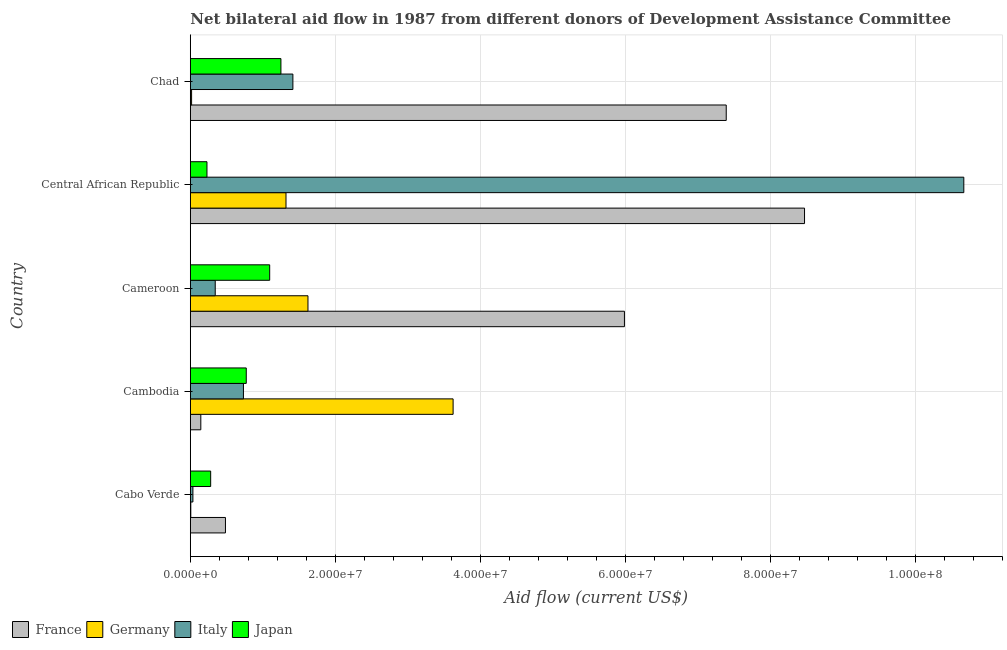How many different coloured bars are there?
Offer a very short reply. 4. How many groups of bars are there?
Your response must be concise. 5. Are the number of bars per tick equal to the number of legend labels?
Offer a terse response. Yes. Are the number of bars on each tick of the Y-axis equal?
Offer a very short reply. Yes. How many bars are there on the 2nd tick from the bottom?
Keep it short and to the point. 4. What is the label of the 2nd group of bars from the top?
Give a very brief answer. Central African Republic. What is the amount of aid given by germany in Cameroon?
Give a very brief answer. 1.62e+07. Across all countries, what is the maximum amount of aid given by italy?
Offer a very short reply. 1.07e+08. Across all countries, what is the minimum amount of aid given by france?
Your response must be concise. 1.45e+06. In which country was the amount of aid given by italy maximum?
Offer a terse response. Central African Republic. In which country was the amount of aid given by france minimum?
Provide a short and direct response. Cambodia. What is the total amount of aid given by france in the graph?
Your answer should be compact. 2.25e+08. What is the difference between the amount of aid given by italy in Cabo Verde and that in Cameroon?
Your answer should be compact. -3.08e+06. What is the difference between the amount of aid given by italy in Central African Republic and the amount of aid given by germany in Cabo Verde?
Offer a terse response. 1.07e+08. What is the average amount of aid given by italy per country?
Your answer should be very brief. 2.64e+07. What is the difference between the amount of aid given by germany and amount of aid given by italy in Cameroon?
Your answer should be very brief. 1.28e+07. What is the ratio of the amount of aid given by italy in Cabo Verde to that in Chad?
Your answer should be compact. 0.03. Is the amount of aid given by japan in Cameroon less than that in Chad?
Keep it short and to the point. Yes. What is the difference between the highest and the second highest amount of aid given by france?
Give a very brief answer. 1.08e+07. What is the difference between the highest and the lowest amount of aid given by france?
Provide a short and direct response. 8.33e+07. Is the sum of the amount of aid given by japan in Cambodia and Central African Republic greater than the maximum amount of aid given by italy across all countries?
Keep it short and to the point. No. Is it the case that in every country, the sum of the amount of aid given by italy and amount of aid given by france is greater than the sum of amount of aid given by japan and amount of aid given by germany?
Offer a very short reply. No. What does the 3rd bar from the top in Chad represents?
Your answer should be compact. Germany. Is it the case that in every country, the sum of the amount of aid given by france and amount of aid given by germany is greater than the amount of aid given by italy?
Make the answer very short. No. How many bars are there?
Offer a very short reply. 20. Are all the bars in the graph horizontal?
Provide a succinct answer. Yes. How many countries are there in the graph?
Make the answer very short. 5. Does the graph contain any zero values?
Provide a succinct answer. No. Does the graph contain grids?
Provide a succinct answer. Yes. Where does the legend appear in the graph?
Offer a terse response. Bottom left. What is the title of the graph?
Provide a succinct answer. Net bilateral aid flow in 1987 from different donors of Development Assistance Committee. Does "Agricultural land" appear as one of the legend labels in the graph?
Provide a succinct answer. No. What is the label or title of the Y-axis?
Your answer should be compact. Country. What is the Aid flow (current US$) in France in Cabo Verde?
Provide a short and direct response. 4.85e+06. What is the Aid flow (current US$) in Germany in Cabo Verde?
Offer a very short reply. 7.00e+04. What is the Aid flow (current US$) of Japan in Cabo Verde?
Offer a terse response. 2.81e+06. What is the Aid flow (current US$) of France in Cambodia?
Make the answer very short. 1.45e+06. What is the Aid flow (current US$) of Germany in Cambodia?
Ensure brevity in your answer.  3.62e+07. What is the Aid flow (current US$) in Italy in Cambodia?
Make the answer very short. 7.33e+06. What is the Aid flow (current US$) in Japan in Cambodia?
Make the answer very short. 7.72e+06. What is the Aid flow (current US$) of France in Cameroon?
Your answer should be very brief. 5.99e+07. What is the Aid flow (current US$) of Germany in Cameroon?
Provide a short and direct response. 1.62e+07. What is the Aid flow (current US$) in Italy in Cameroon?
Provide a short and direct response. 3.44e+06. What is the Aid flow (current US$) in Japan in Cameroon?
Your answer should be compact. 1.10e+07. What is the Aid flow (current US$) in France in Central African Republic?
Provide a succinct answer. 8.47e+07. What is the Aid flow (current US$) of Germany in Central African Republic?
Provide a succinct answer. 1.32e+07. What is the Aid flow (current US$) of Italy in Central African Republic?
Offer a very short reply. 1.07e+08. What is the Aid flow (current US$) of Japan in Central African Republic?
Your answer should be compact. 2.30e+06. What is the Aid flow (current US$) in France in Chad?
Provide a short and direct response. 7.39e+07. What is the Aid flow (current US$) of Germany in Chad?
Provide a short and direct response. 1.80e+05. What is the Aid flow (current US$) of Italy in Chad?
Give a very brief answer. 1.42e+07. What is the Aid flow (current US$) of Japan in Chad?
Give a very brief answer. 1.25e+07. Across all countries, what is the maximum Aid flow (current US$) in France?
Your response must be concise. 8.47e+07. Across all countries, what is the maximum Aid flow (current US$) of Germany?
Your response must be concise. 3.62e+07. Across all countries, what is the maximum Aid flow (current US$) of Italy?
Offer a very short reply. 1.07e+08. Across all countries, what is the maximum Aid flow (current US$) of Japan?
Ensure brevity in your answer.  1.25e+07. Across all countries, what is the minimum Aid flow (current US$) of France?
Make the answer very short. 1.45e+06. Across all countries, what is the minimum Aid flow (current US$) of Germany?
Keep it short and to the point. 7.00e+04. Across all countries, what is the minimum Aid flow (current US$) in Japan?
Ensure brevity in your answer.  2.30e+06. What is the total Aid flow (current US$) in France in the graph?
Ensure brevity in your answer.  2.25e+08. What is the total Aid flow (current US$) of Germany in the graph?
Your response must be concise. 6.59e+07. What is the total Aid flow (current US$) of Italy in the graph?
Your response must be concise. 1.32e+08. What is the total Aid flow (current US$) of Japan in the graph?
Your answer should be very brief. 3.63e+07. What is the difference between the Aid flow (current US$) in France in Cabo Verde and that in Cambodia?
Keep it short and to the point. 3.40e+06. What is the difference between the Aid flow (current US$) of Germany in Cabo Verde and that in Cambodia?
Make the answer very short. -3.62e+07. What is the difference between the Aid flow (current US$) in Italy in Cabo Verde and that in Cambodia?
Offer a terse response. -6.97e+06. What is the difference between the Aid flow (current US$) of Japan in Cabo Verde and that in Cambodia?
Offer a terse response. -4.91e+06. What is the difference between the Aid flow (current US$) in France in Cabo Verde and that in Cameroon?
Your answer should be compact. -5.50e+07. What is the difference between the Aid flow (current US$) of Germany in Cabo Verde and that in Cameroon?
Offer a terse response. -1.62e+07. What is the difference between the Aid flow (current US$) of Italy in Cabo Verde and that in Cameroon?
Ensure brevity in your answer.  -3.08e+06. What is the difference between the Aid flow (current US$) of Japan in Cabo Verde and that in Cameroon?
Your response must be concise. -8.14e+06. What is the difference between the Aid flow (current US$) of France in Cabo Verde and that in Central African Republic?
Make the answer very short. -7.99e+07. What is the difference between the Aid flow (current US$) in Germany in Cabo Verde and that in Central African Republic?
Ensure brevity in your answer.  -1.31e+07. What is the difference between the Aid flow (current US$) in Italy in Cabo Verde and that in Central African Republic?
Keep it short and to the point. -1.06e+08. What is the difference between the Aid flow (current US$) in Japan in Cabo Verde and that in Central African Republic?
Your answer should be very brief. 5.10e+05. What is the difference between the Aid flow (current US$) of France in Cabo Verde and that in Chad?
Your answer should be compact. -6.91e+07. What is the difference between the Aid flow (current US$) of Italy in Cabo Verde and that in Chad?
Provide a succinct answer. -1.38e+07. What is the difference between the Aid flow (current US$) in Japan in Cabo Verde and that in Chad?
Ensure brevity in your answer.  -9.69e+06. What is the difference between the Aid flow (current US$) in France in Cambodia and that in Cameroon?
Ensure brevity in your answer.  -5.84e+07. What is the difference between the Aid flow (current US$) in Germany in Cambodia and that in Cameroon?
Give a very brief answer. 2.00e+07. What is the difference between the Aid flow (current US$) in Italy in Cambodia and that in Cameroon?
Offer a very short reply. 3.89e+06. What is the difference between the Aid flow (current US$) in Japan in Cambodia and that in Cameroon?
Provide a succinct answer. -3.23e+06. What is the difference between the Aid flow (current US$) in France in Cambodia and that in Central African Republic?
Your answer should be very brief. -8.33e+07. What is the difference between the Aid flow (current US$) of Germany in Cambodia and that in Central African Republic?
Provide a succinct answer. 2.30e+07. What is the difference between the Aid flow (current US$) in Italy in Cambodia and that in Central African Republic?
Provide a succinct answer. -9.94e+07. What is the difference between the Aid flow (current US$) of Japan in Cambodia and that in Central African Republic?
Provide a short and direct response. 5.42e+06. What is the difference between the Aid flow (current US$) of France in Cambodia and that in Chad?
Provide a short and direct response. -7.25e+07. What is the difference between the Aid flow (current US$) of Germany in Cambodia and that in Chad?
Keep it short and to the point. 3.61e+07. What is the difference between the Aid flow (current US$) in Italy in Cambodia and that in Chad?
Offer a very short reply. -6.82e+06. What is the difference between the Aid flow (current US$) in Japan in Cambodia and that in Chad?
Your response must be concise. -4.78e+06. What is the difference between the Aid flow (current US$) in France in Cameroon and that in Central African Republic?
Your answer should be very brief. -2.48e+07. What is the difference between the Aid flow (current US$) of Germany in Cameroon and that in Central African Republic?
Provide a short and direct response. 3.03e+06. What is the difference between the Aid flow (current US$) in Italy in Cameroon and that in Central African Republic?
Your response must be concise. -1.03e+08. What is the difference between the Aid flow (current US$) in Japan in Cameroon and that in Central African Republic?
Give a very brief answer. 8.65e+06. What is the difference between the Aid flow (current US$) of France in Cameroon and that in Chad?
Your answer should be very brief. -1.40e+07. What is the difference between the Aid flow (current US$) of Germany in Cameroon and that in Chad?
Give a very brief answer. 1.60e+07. What is the difference between the Aid flow (current US$) in Italy in Cameroon and that in Chad?
Offer a very short reply. -1.07e+07. What is the difference between the Aid flow (current US$) in Japan in Cameroon and that in Chad?
Provide a short and direct response. -1.55e+06. What is the difference between the Aid flow (current US$) in France in Central African Republic and that in Chad?
Offer a very short reply. 1.08e+07. What is the difference between the Aid flow (current US$) in Germany in Central African Republic and that in Chad?
Make the answer very short. 1.30e+07. What is the difference between the Aid flow (current US$) of Italy in Central African Republic and that in Chad?
Make the answer very short. 9.25e+07. What is the difference between the Aid flow (current US$) in Japan in Central African Republic and that in Chad?
Offer a terse response. -1.02e+07. What is the difference between the Aid flow (current US$) of France in Cabo Verde and the Aid flow (current US$) of Germany in Cambodia?
Make the answer very short. -3.14e+07. What is the difference between the Aid flow (current US$) of France in Cabo Verde and the Aid flow (current US$) of Italy in Cambodia?
Give a very brief answer. -2.48e+06. What is the difference between the Aid flow (current US$) of France in Cabo Verde and the Aid flow (current US$) of Japan in Cambodia?
Ensure brevity in your answer.  -2.87e+06. What is the difference between the Aid flow (current US$) in Germany in Cabo Verde and the Aid flow (current US$) in Italy in Cambodia?
Keep it short and to the point. -7.26e+06. What is the difference between the Aid flow (current US$) in Germany in Cabo Verde and the Aid flow (current US$) in Japan in Cambodia?
Offer a terse response. -7.65e+06. What is the difference between the Aid flow (current US$) of Italy in Cabo Verde and the Aid flow (current US$) of Japan in Cambodia?
Your response must be concise. -7.36e+06. What is the difference between the Aid flow (current US$) of France in Cabo Verde and the Aid flow (current US$) of Germany in Cameroon?
Offer a terse response. -1.14e+07. What is the difference between the Aid flow (current US$) in France in Cabo Verde and the Aid flow (current US$) in Italy in Cameroon?
Make the answer very short. 1.41e+06. What is the difference between the Aid flow (current US$) of France in Cabo Verde and the Aid flow (current US$) of Japan in Cameroon?
Provide a succinct answer. -6.10e+06. What is the difference between the Aid flow (current US$) in Germany in Cabo Verde and the Aid flow (current US$) in Italy in Cameroon?
Give a very brief answer. -3.37e+06. What is the difference between the Aid flow (current US$) in Germany in Cabo Verde and the Aid flow (current US$) in Japan in Cameroon?
Give a very brief answer. -1.09e+07. What is the difference between the Aid flow (current US$) of Italy in Cabo Verde and the Aid flow (current US$) of Japan in Cameroon?
Your answer should be compact. -1.06e+07. What is the difference between the Aid flow (current US$) of France in Cabo Verde and the Aid flow (current US$) of Germany in Central African Republic?
Offer a terse response. -8.35e+06. What is the difference between the Aid flow (current US$) of France in Cabo Verde and the Aid flow (current US$) of Italy in Central African Republic?
Your answer should be compact. -1.02e+08. What is the difference between the Aid flow (current US$) of France in Cabo Verde and the Aid flow (current US$) of Japan in Central African Republic?
Make the answer very short. 2.55e+06. What is the difference between the Aid flow (current US$) in Germany in Cabo Verde and the Aid flow (current US$) in Italy in Central African Republic?
Your response must be concise. -1.07e+08. What is the difference between the Aid flow (current US$) in Germany in Cabo Verde and the Aid flow (current US$) in Japan in Central African Republic?
Your response must be concise. -2.23e+06. What is the difference between the Aid flow (current US$) in Italy in Cabo Verde and the Aid flow (current US$) in Japan in Central African Republic?
Offer a very short reply. -1.94e+06. What is the difference between the Aid flow (current US$) in France in Cabo Verde and the Aid flow (current US$) in Germany in Chad?
Your answer should be compact. 4.67e+06. What is the difference between the Aid flow (current US$) of France in Cabo Verde and the Aid flow (current US$) of Italy in Chad?
Keep it short and to the point. -9.30e+06. What is the difference between the Aid flow (current US$) in France in Cabo Verde and the Aid flow (current US$) in Japan in Chad?
Offer a very short reply. -7.65e+06. What is the difference between the Aid flow (current US$) in Germany in Cabo Verde and the Aid flow (current US$) in Italy in Chad?
Ensure brevity in your answer.  -1.41e+07. What is the difference between the Aid flow (current US$) of Germany in Cabo Verde and the Aid flow (current US$) of Japan in Chad?
Your answer should be very brief. -1.24e+07. What is the difference between the Aid flow (current US$) in Italy in Cabo Verde and the Aid flow (current US$) in Japan in Chad?
Your answer should be very brief. -1.21e+07. What is the difference between the Aid flow (current US$) in France in Cambodia and the Aid flow (current US$) in Germany in Cameroon?
Ensure brevity in your answer.  -1.48e+07. What is the difference between the Aid flow (current US$) in France in Cambodia and the Aid flow (current US$) in Italy in Cameroon?
Offer a very short reply. -1.99e+06. What is the difference between the Aid flow (current US$) in France in Cambodia and the Aid flow (current US$) in Japan in Cameroon?
Your answer should be compact. -9.50e+06. What is the difference between the Aid flow (current US$) of Germany in Cambodia and the Aid flow (current US$) of Italy in Cameroon?
Provide a short and direct response. 3.28e+07. What is the difference between the Aid flow (current US$) in Germany in Cambodia and the Aid flow (current US$) in Japan in Cameroon?
Your answer should be very brief. 2.53e+07. What is the difference between the Aid flow (current US$) in Italy in Cambodia and the Aid flow (current US$) in Japan in Cameroon?
Ensure brevity in your answer.  -3.62e+06. What is the difference between the Aid flow (current US$) of France in Cambodia and the Aid flow (current US$) of Germany in Central African Republic?
Offer a very short reply. -1.18e+07. What is the difference between the Aid flow (current US$) of France in Cambodia and the Aid flow (current US$) of Italy in Central African Republic?
Make the answer very short. -1.05e+08. What is the difference between the Aid flow (current US$) in France in Cambodia and the Aid flow (current US$) in Japan in Central African Republic?
Give a very brief answer. -8.50e+05. What is the difference between the Aid flow (current US$) in Germany in Cambodia and the Aid flow (current US$) in Italy in Central African Republic?
Your answer should be very brief. -7.04e+07. What is the difference between the Aid flow (current US$) of Germany in Cambodia and the Aid flow (current US$) of Japan in Central African Republic?
Make the answer very short. 3.40e+07. What is the difference between the Aid flow (current US$) in Italy in Cambodia and the Aid flow (current US$) in Japan in Central African Republic?
Offer a very short reply. 5.03e+06. What is the difference between the Aid flow (current US$) in France in Cambodia and the Aid flow (current US$) in Germany in Chad?
Provide a succinct answer. 1.27e+06. What is the difference between the Aid flow (current US$) of France in Cambodia and the Aid flow (current US$) of Italy in Chad?
Your answer should be very brief. -1.27e+07. What is the difference between the Aid flow (current US$) in France in Cambodia and the Aid flow (current US$) in Japan in Chad?
Your answer should be very brief. -1.10e+07. What is the difference between the Aid flow (current US$) in Germany in Cambodia and the Aid flow (current US$) in Italy in Chad?
Make the answer very short. 2.21e+07. What is the difference between the Aid flow (current US$) in Germany in Cambodia and the Aid flow (current US$) in Japan in Chad?
Keep it short and to the point. 2.38e+07. What is the difference between the Aid flow (current US$) of Italy in Cambodia and the Aid flow (current US$) of Japan in Chad?
Your answer should be compact. -5.17e+06. What is the difference between the Aid flow (current US$) of France in Cameroon and the Aid flow (current US$) of Germany in Central African Republic?
Keep it short and to the point. 4.67e+07. What is the difference between the Aid flow (current US$) of France in Cameroon and the Aid flow (current US$) of Italy in Central African Republic?
Provide a short and direct response. -4.68e+07. What is the difference between the Aid flow (current US$) of France in Cameroon and the Aid flow (current US$) of Japan in Central African Republic?
Make the answer very short. 5.76e+07. What is the difference between the Aid flow (current US$) in Germany in Cameroon and the Aid flow (current US$) in Italy in Central African Republic?
Provide a short and direct response. -9.05e+07. What is the difference between the Aid flow (current US$) of Germany in Cameroon and the Aid flow (current US$) of Japan in Central African Republic?
Your answer should be very brief. 1.39e+07. What is the difference between the Aid flow (current US$) of Italy in Cameroon and the Aid flow (current US$) of Japan in Central African Republic?
Keep it short and to the point. 1.14e+06. What is the difference between the Aid flow (current US$) in France in Cameroon and the Aid flow (current US$) in Germany in Chad?
Make the answer very short. 5.97e+07. What is the difference between the Aid flow (current US$) in France in Cameroon and the Aid flow (current US$) in Italy in Chad?
Provide a short and direct response. 4.57e+07. What is the difference between the Aid flow (current US$) of France in Cameroon and the Aid flow (current US$) of Japan in Chad?
Your answer should be very brief. 4.74e+07. What is the difference between the Aid flow (current US$) of Germany in Cameroon and the Aid flow (current US$) of Italy in Chad?
Provide a short and direct response. 2.08e+06. What is the difference between the Aid flow (current US$) in Germany in Cameroon and the Aid flow (current US$) in Japan in Chad?
Offer a terse response. 3.73e+06. What is the difference between the Aid flow (current US$) of Italy in Cameroon and the Aid flow (current US$) of Japan in Chad?
Your response must be concise. -9.06e+06. What is the difference between the Aid flow (current US$) of France in Central African Republic and the Aid flow (current US$) of Germany in Chad?
Keep it short and to the point. 8.45e+07. What is the difference between the Aid flow (current US$) of France in Central African Republic and the Aid flow (current US$) of Italy in Chad?
Make the answer very short. 7.06e+07. What is the difference between the Aid flow (current US$) in France in Central African Republic and the Aid flow (current US$) in Japan in Chad?
Provide a succinct answer. 7.22e+07. What is the difference between the Aid flow (current US$) of Germany in Central African Republic and the Aid flow (current US$) of Italy in Chad?
Offer a terse response. -9.50e+05. What is the difference between the Aid flow (current US$) of Germany in Central African Republic and the Aid flow (current US$) of Japan in Chad?
Offer a very short reply. 7.00e+05. What is the difference between the Aid flow (current US$) of Italy in Central African Republic and the Aid flow (current US$) of Japan in Chad?
Offer a very short reply. 9.42e+07. What is the average Aid flow (current US$) of France per country?
Your answer should be very brief. 4.50e+07. What is the average Aid flow (current US$) of Germany per country?
Ensure brevity in your answer.  1.32e+07. What is the average Aid flow (current US$) of Italy per country?
Provide a short and direct response. 2.64e+07. What is the average Aid flow (current US$) of Japan per country?
Keep it short and to the point. 7.26e+06. What is the difference between the Aid flow (current US$) in France and Aid flow (current US$) in Germany in Cabo Verde?
Your answer should be compact. 4.78e+06. What is the difference between the Aid flow (current US$) of France and Aid flow (current US$) of Italy in Cabo Verde?
Your response must be concise. 4.49e+06. What is the difference between the Aid flow (current US$) in France and Aid flow (current US$) in Japan in Cabo Verde?
Offer a very short reply. 2.04e+06. What is the difference between the Aid flow (current US$) in Germany and Aid flow (current US$) in Italy in Cabo Verde?
Your answer should be compact. -2.90e+05. What is the difference between the Aid flow (current US$) in Germany and Aid flow (current US$) in Japan in Cabo Verde?
Ensure brevity in your answer.  -2.74e+06. What is the difference between the Aid flow (current US$) of Italy and Aid flow (current US$) of Japan in Cabo Verde?
Make the answer very short. -2.45e+06. What is the difference between the Aid flow (current US$) of France and Aid flow (current US$) of Germany in Cambodia?
Your answer should be very brief. -3.48e+07. What is the difference between the Aid flow (current US$) in France and Aid flow (current US$) in Italy in Cambodia?
Offer a very short reply. -5.88e+06. What is the difference between the Aid flow (current US$) of France and Aid flow (current US$) of Japan in Cambodia?
Keep it short and to the point. -6.27e+06. What is the difference between the Aid flow (current US$) of Germany and Aid flow (current US$) of Italy in Cambodia?
Provide a short and direct response. 2.89e+07. What is the difference between the Aid flow (current US$) in Germany and Aid flow (current US$) in Japan in Cambodia?
Your response must be concise. 2.85e+07. What is the difference between the Aid flow (current US$) of Italy and Aid flow (current US$) of Japan in Cambodia?
Keep it short and to the point. -3.90e+05. What is the difference between the Aid flow (current US$) of France and Aid flow (current US$) of Germany in Cameroon?
Your answer should be compact. 4.36e+07. What is the difference between the Aid flow (current US$) of France and Aid flow (current US$) of Italy in Cameroon?
Your answer should be very brief. 5.64e+07. What is the difference between the Aid flow (current US$) of France and Aid flow (current US$) of Japan in Cameroon?
Provide a succinct answer. 4.89e+07. What is the difference between the Aid flow (current US$) in Germany and Aid flow (current US$) in Italy in Cameroon?
Give a very brief answer. 1.28e+07. What is the difference between the Aid flow (current US$) of Germany and Aid flow (current US$) of Japan in Cameroon?
Your response must be concise. 5.28e+06. What is the difference between the Aid flow (current US$) of Italy and Aid flow (current US$) of Japan in Cameroon?
Your response must be concise. -7.51e+06. What is the difference between the Aid flow (current US$) in France and Aid flow (current US$) in Germany in Central African Republic?
Your answer should be compact. 7.15e+07. What is the difference between the Aid flow (current US$) in France and Aid flow (current US$) in Italy in Central African Republic?
Your response must be concise. -2.20e+07. What is the difference between the Aid flow (current US$) of France and Aid flow (current US$) of Japan in Central African Republic?
Offer a terse response. 8.24e+07. What is the difference between the Aid flow (current US$) of Germany and Aid flow (current US$) of Italy in Central African Republic?
Your answer should be compact. -9.35e+07. What is the difference between the Aid flow (current US$) of Germany and Aid flow (current US$) of Japan in Central African Republic?
Your answer should be compact. 1.09e+07. What is the difference between the Aid flow (current US$) of Italy and Aid flow (current US$) of Japan in Central African Republic?
Your answer should be very brief. 1.04e+08. What is the difference between the Aid flow (current US$) of France and Aid flow (current US$) of Germany in Chad?
Keep it short and to the point. 7.37e+07. What is the difference between the Aid flow (current US$) in France and Aid flow (current US$) in Italy in Chad?
Keep it short and to the point. 5.98e+07. What is the difference between the Aid flow (current US$) of France and Aid flow (current US$) of Japan in Chad?
Your response must be concise. 6.14e+07. What is the difference between the Aid flow (current US$) in Germany and Aid flow (current US$) in Italy in Chad?
Give a very brief answer. -1.40e+07. What is the difference between the Aid flow (current US$) in Germany and Aid flow (current US$) in Japan in Chad?
Offer a terse response. -1.23e+07. What is the difference between the Aid flow (current US$) in Italy and Aid flow (current US$) in Japan in Chad?
Provide a succinct answer. 1.65e+06. What is the ratio of the Aid flow (current US$) in France in Cabo Verde to that in Cambodia?
Keep it short and to the point. 3.34. What is the ratio of the Aid flow (current US$) of Germany in Cabo Verde to that in Cambodia?
Your answer should be very brief. 0. What is the ratio of the Aid flow (current US$) in Italy in Cabo Verde to that in Cambodia?
Offer a very short reply. 0.05. What is the ratio of the Aid flow (current US$) of Japan in Cabo Verde to that in Cambodia?
Give a very brief answer. 0.36. What is the ratio of the Aid flow (current US$) in France in Cabo Verde to that in Cameroon?
Your answer should be very brief. 0.08. What is the ratio of the Aid flow (current US$) in Germany in Cabo Verde to that in Cameroon?
Ensure brevity in your answer.  0. What is the ratio of the Aid flow (current US$) in Italy in Cabo Verde to that in Cameroon?
Offer a very short reply. 0.1. What is the ratio of the Aid flow (current US$) of Japan in Cabo Verde to that in Cameroon?
Your response must be concise. 0.26. What is the ratio of the Aid flow (current US$) in France in Cabo Verde to that in Central African Republic?
Provide a succinct answer. 0.06. What is the ratio of the Aid flow (current US$) in Germany in Cabo Verde to that in Central African Republic?
Your response must be concise. 0.01. What is the ratio of the Aid flow (current US$) in Italy in Cabo Verde to that in Central African Republic?
Make the answer very short. 0. What is the ratio of the Aid flow (current US$) in Japan in Cabo Verde to that in Central African Republic?
Provide a succinct answer. 1.22. What is the ratio of the Aid flow (current US$) of France in Cabo Verde to that in Chad?
Offer a terse response. 0.07. What is the ratio of the Aid flow (current US$) of Germany in Cabo Verde to that in Chad?
Ensure brevity in your answer.  0.39. What is the ratio of the Aid flow (current US$) in Italy in Cabo Verde to that in Chad?
Offer a terse response. 0.03. What is the ratio of the Aid flow (current US$) of Japan in Cabo Verde to that in Chad?
Give a very brief answer. 0.22. What is the ratio of the Aid flow (current US$) of France in Cambodia to that in Cameroon?
Your answer should be compact. 0.02. What is the ratio of the Aid flow (current US$) in Germany in Cambodia to that in Cameroon?
Offer a very short reply. 2.23. What is the ratio of the Aid flow (current US$) of Italy in Cambodia to that in Cameroon?
Offer a very short reply. 2.13. What is the ratio of the Aid flow (current US$) in Japan in Cambodia to that in Cameroon?
Your response must be concise. 0.7. What is the ratio of the Aid flow (current US$) of France in Cambodia to that in Central African Republic?
Your response must be concise. 0.02. What is the ratio of the Aid flow (current US$) in Germany in Cambodia to that in Central African Republic?
Ensure brevity in your answer.  2.75. What is the ratio of the Aid flow (current US$) of Italy in Cambodia to that in Central African Republic?
Provide a short and direct response. 0.07. What is the ratio of the Aid flow (current US$) in Japan in Cambodia to that in Central African Republic?
Give a very brief answer. 3.36. What is the ratio of the Aid flow (current US$) of France in Cambodia to that in Chad?
Make the answer very short. 0.02. What is the ratio of the Aid flow (current US$) of Germany in Cambodia to that in Chad?
Your response must be concise. 201.39. What is the ratio of the Aid flow (current US$) in Italy in Cambodia to that in Chad?
Your answer should be compact. 0.52. What is the ratio of the Aid flow (current US$) of Japan in Cambodia to that in Chad?
Offer a terse response. 0.62. What is the ratio of the Aid flow (current US$) of France in Cameroon to that in Central African Republic?
Offer a very short reply. 0.71. What is the ratio of the Aid flow (current US$) in Germany in Cameroon to that in Central African Republic?
Your answer should be very brief. 1.23. What is the ratio of the Aid flow (current US$) of Italy in Cameroon to that in Central African Republic?
Keep it short and to the point. 0.03. What is the ratio of the Aid flow (current US$) of Japan in Cameroon to that in Central African Republic?
Offer a terse response. 4.76. What is the ratio of the Aid flow (current US$) in France in Cameroon to that in Chad?
Offer a terse response. 0.81. What is the ratio of the Aid flow (current US$) in Germany in Cameroon to that in Chad?
Offer a very short reply. 90.17. What is the ratio of the Aid flow (current US$) in Italy in Cameroon to that in Chad?
Give a very brief answer. 0.24. What is the ratio of the Aid flow (current US$) of Japan in Cameroon to that in Chad?
Keep it short and to the point. 0.88. What is the ratio of the Aid flow (current US$) in France in Central African Republic to that in Chad?
Ensure brevity in your answer.  1.15. What is the ratio of the Aid flow (current US$) in Germany in Central African Republic to that in Chad?
Your answer should be compact. 73.33. What is the ratio of the Aid flow (current US$) in Italy in Central African Republic to that in Chad?
Offer a terse response. 7.54. What is the ratio of the Aid flow (current US$) in Japan in Central African Republic to that in Chad?
Provide a succinct answer. 0.18. What is the difference between the highest and the second highest Aid flow (current US$) of France?
Offer a terse response. 1.08e+07. What is the difference between the highest and the second highest Aid flow (current US$) in Germany?
Provide a succinct answer. 2.00e+07. What is the difference between the highest and the second highest Aid flow (current US$) in Italy?
Ensure brevity in your answer.  9.25e+07. What is the difference between the highest and the second highest Aid flow (current US$) in Japan?
Offer a very short reply. 1.55e+06. What is the difference between the highest and the lowest Aid flow (current US$) in France?
Provide a succinct answer. 8.33e+07. What is the difference between the highest and the lowest Aid flow (current US$) of Germany?
Offer a very short reply. 3.62e+07. What is the difference between the highest and the lowest Aid flow (current US$) in Italy?
Offer a very short reply. 1.06e+08. What is the difference between the highest and the lowest Aid flow (current US$) in Japan?
Offer a very short reply. 1.02e+07. 